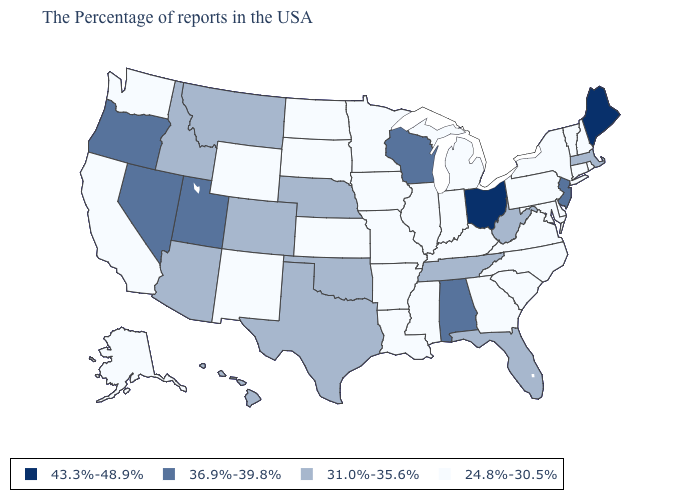What is the value of Minnesota?
Concise answer only. 24.8%-30.5%. Which states hav the highest value in the MidWest?
Concise answer only. Ohio. What is the value of New Hampshire?
Answer briefly. 24.8%-30.5%. Does Nevada have the highest value in the West?
Answer briefly. Yes. What is the value of Nevada?
Concise answer only. 36.9%-39.8%. Name the states that have a value in the range 43.3%-48.9%?
Quick response, please. Maine, Ohio. What is the highest value in the USA?
Answer briefly. 43.3%-48.9%. Does Alaska have the lowest value in the West?
Short answer required. Yes. What is the value of Alabama?
Quick response, please. 36.9%-39.8%. What is the value of South Carolina?
Answer briefly. 24.8%-30.5%. What is the lowest value in states that border New Hampshire?
Quick response, please. 24.8%-30.5%. Name the states that have a value in the range 36.9%-39.8%?
Keep it brief. New Jersey, Alabama, Wisconsin, Utah, Nevada, Oregon. Name the states that have a value in the range 43.3%-48.9%?
Keep it brief. Maine, Ohio. Which states hav the highest value in the Northeast?
Write a very short answer. Maine. 